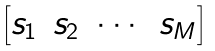<formula> <loc_0><loc_0><loc_500><loc_500>\begin{bmatrix} s _ { 1 } & s _ { 2 } & \cdots & s _ { M } \end{bmatrix}</formula> 